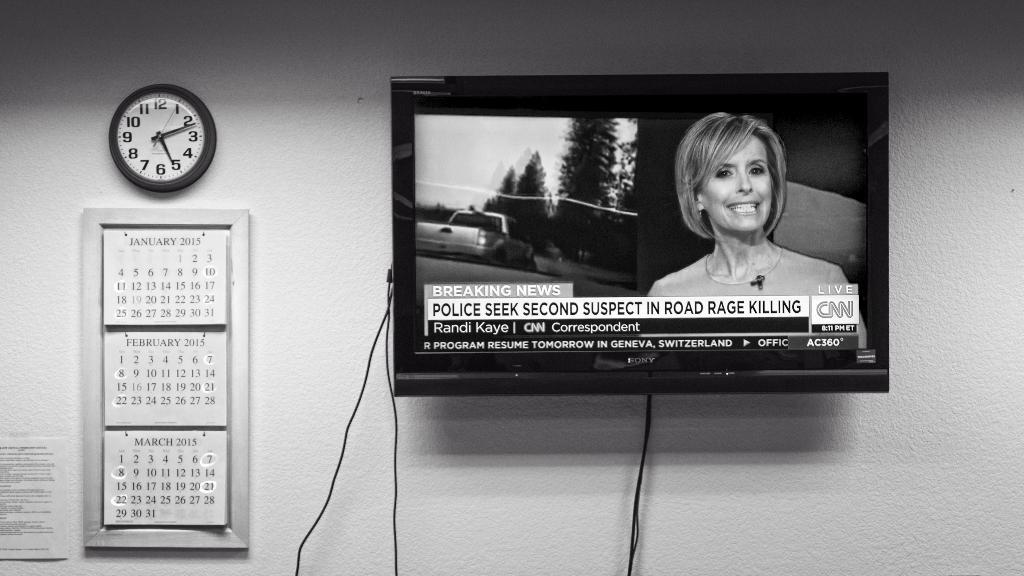<image>
Relay a brief, clear account of the picture shown. A news reporter is talking about a suspect that was caught in a road rage accident 